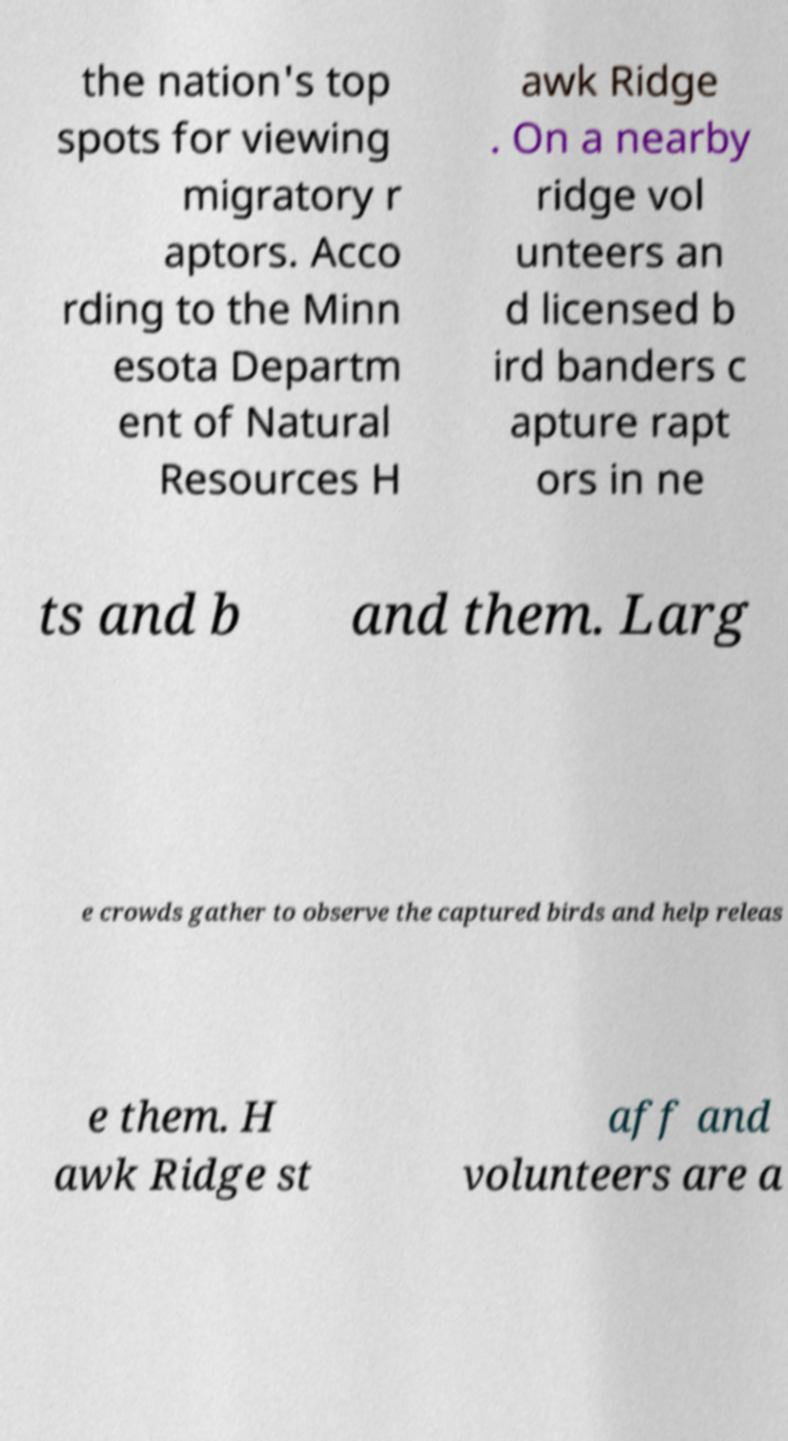Can you read and provide the text displayed in the image?This photo seems to have some interesting text. Can you extract and type it out for me? the nation's top spots for viewing migratory r aptors. Acco rding to the Minn esota Departm ent of Natural Resources H awk Ridge . On a nearby ridge vol unteers an d licensed b ird banders c apture rapt ors in ne ts and b and them. Larg e crowds gather to observe the captured birds and help releas e them. H awk Ridge st aff and volunteers are a 